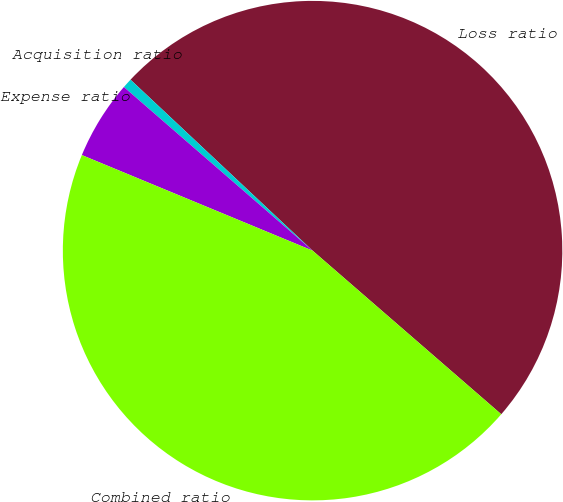<chart> <loc_0><loc_0><loc_500><loc_500><pie_chart><fcel>Loss ratio<fcel>Acquisition ratio<fcel>Expense ratio<fcel>Combined ratio<nl><fcel>49.37%<fcel>0.63%<fcel>5.12%<fcel>44.88%<nl></chart> 